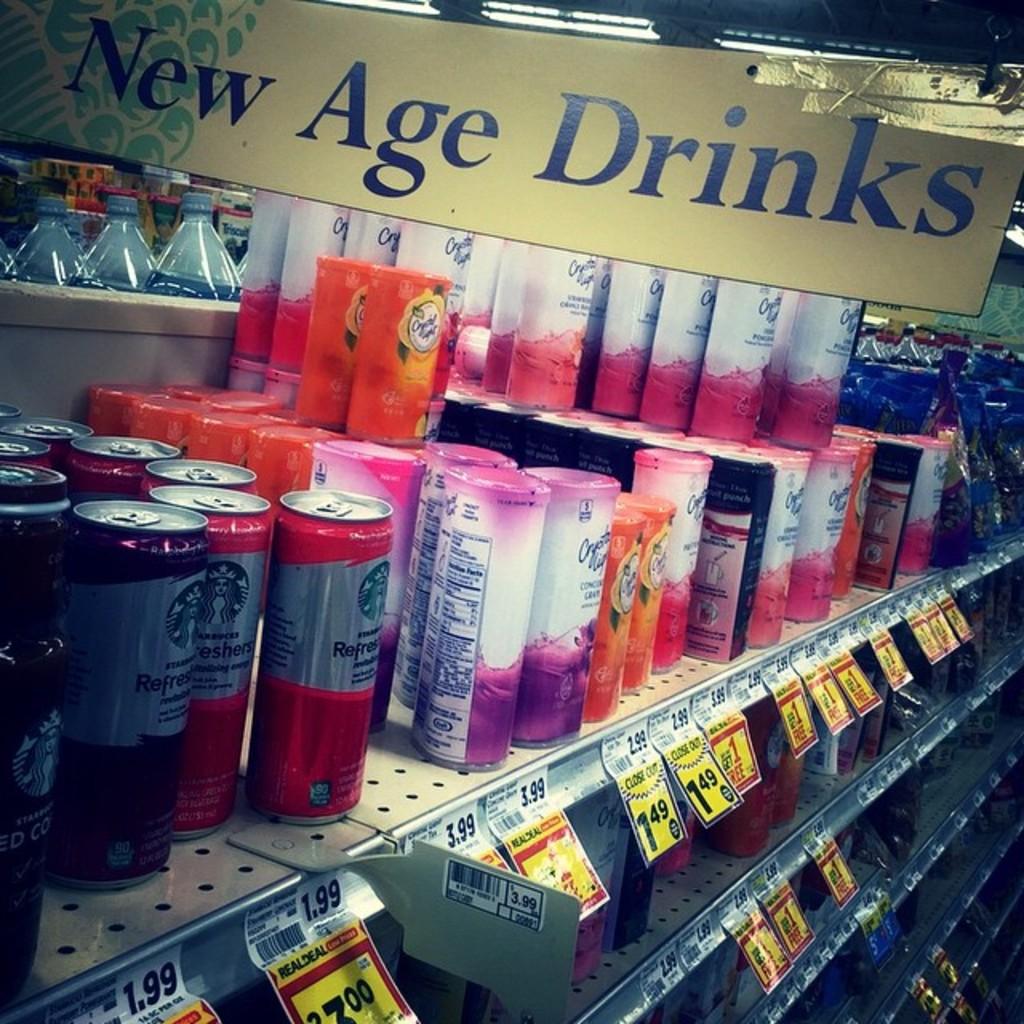What catagory of drinks are in this section?
Offer a very short reply. New age. This is tshirt?
Give a very brief answer. No. 